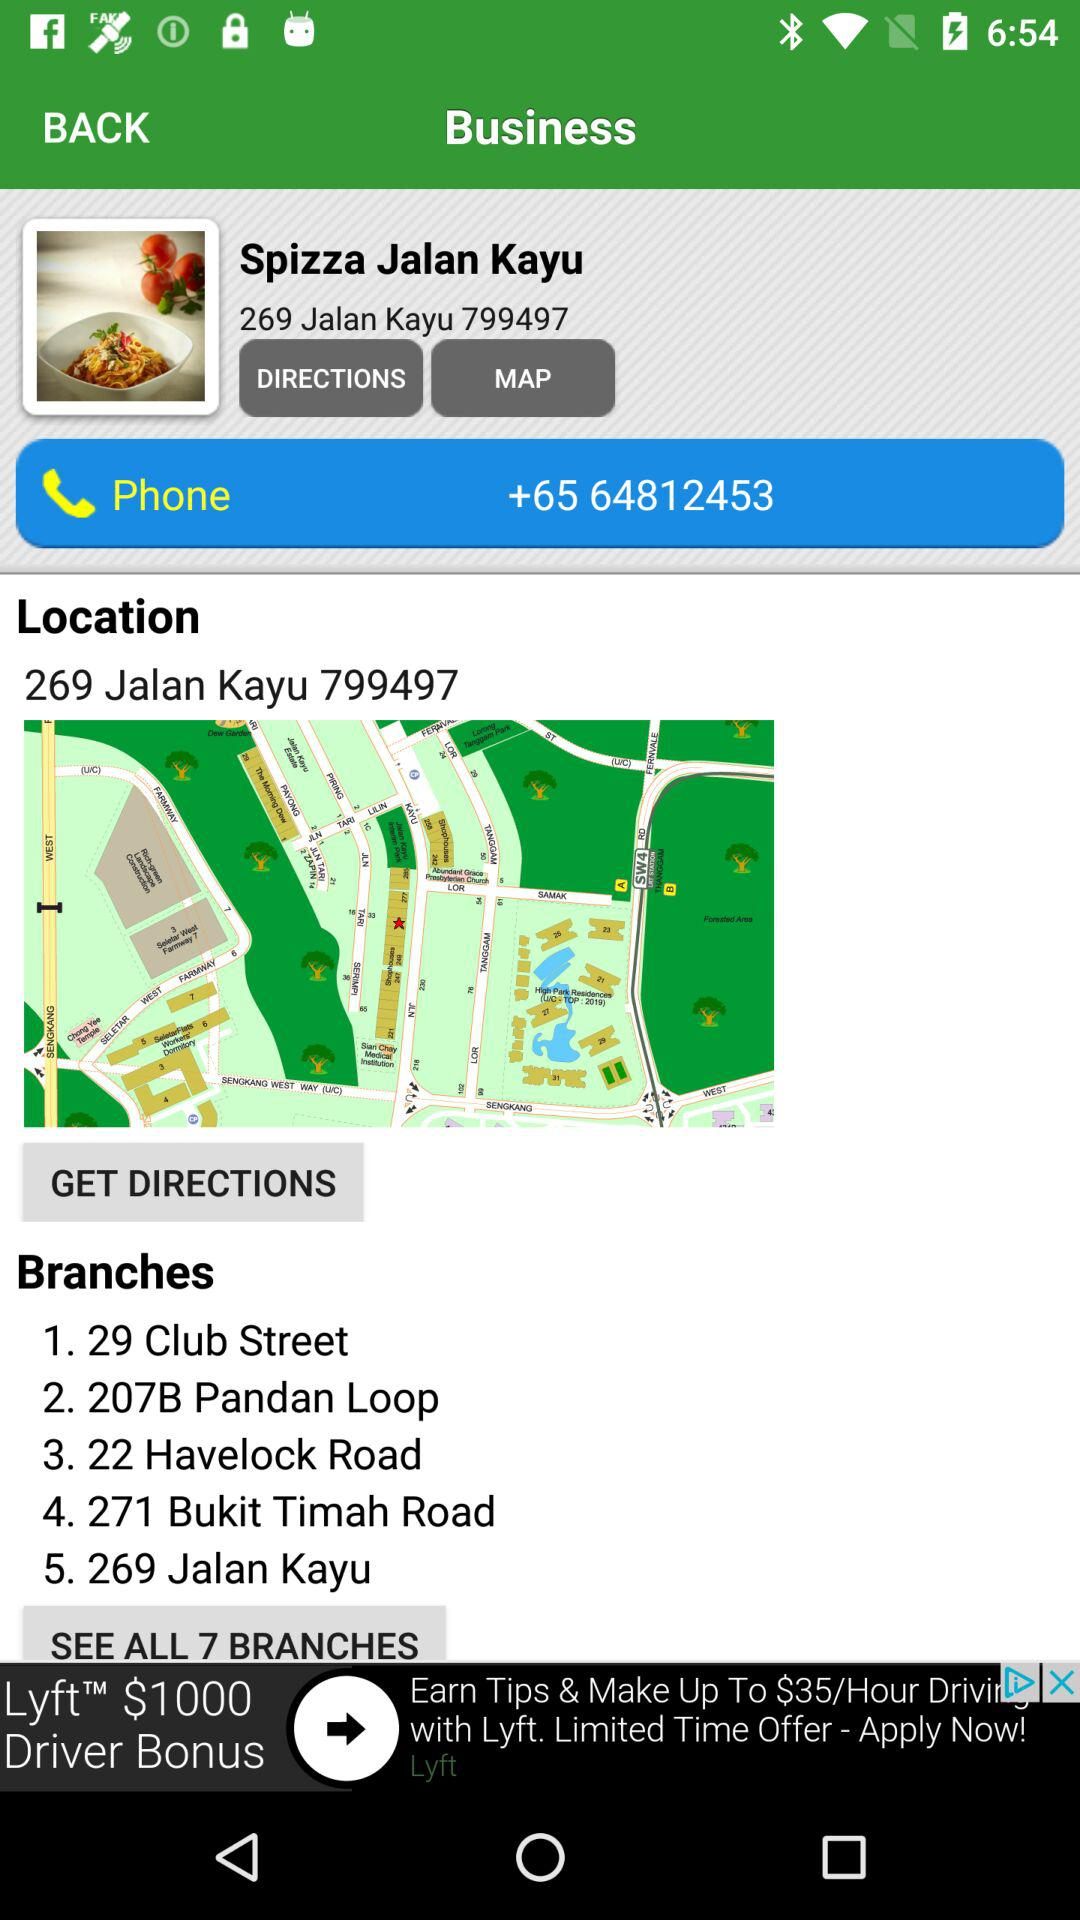How many phone numbers does Spizza Jalan Kayu have?
Answer the question using a single word or phrase. 1 